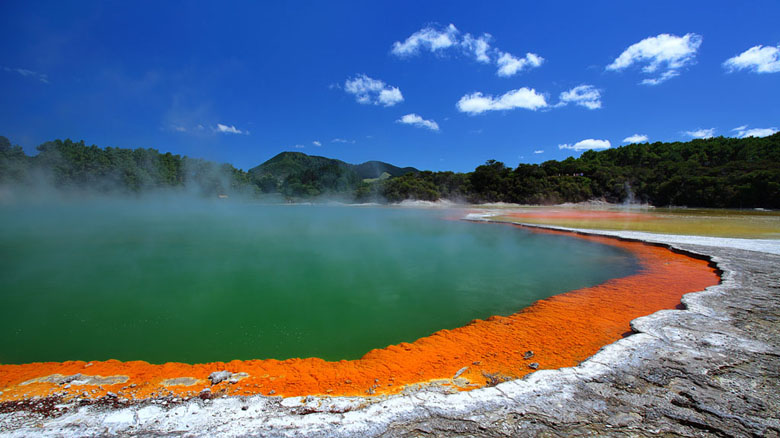If you could step into this image, what would you experience? Stepping into this image, you would be greeted by the warm, humid air and the unmistakable scent of sulfur from the geothermal activity. The ground beneath your feet might feel warm and slightly yielding from the mineral deposits and thermal heat. The vibrant orange and green hues of the hot spring would captivate your senses, and the rising steam would create an ethereal, almost otherworldly atmosphere. The distant mountains and the lush greenery would add to the serene and picturesque landscape, making you feel as though you have stepped into a natural wonderland. Can you tell me more about the geothermal processes that create such landscapes? Geothermal landscapes like the one in Wai-O-Tapu Thermal Wonderland are formed by the heat from the Earth's interior. This geothermal activity typically occurs in regions with significant volcanic activity. Magma from beneath the Earth's crust heats the groundwater, which can then rise to the surface through cracks and fissures. When this superheated water reaches the surface, it can form geysers, hot springs, mud pools, and fumaroles.

The vibrant colors in these geothermal features are due to a combination of high mineral content and the presence of thermophilic microorganisms. For instance, the bright orange rim of the hot spring in the image is mainly caused by deposits of sulfur and iron oxide, which precipitate out of the hot water. The green color in the center indicates the presence of certain types of algae and bacteria that can survive in hot, mineral-rich waters. These microorganisms contribute to the color while thriving in such extreme conditions, showcasing the incredible adaptability of life. 